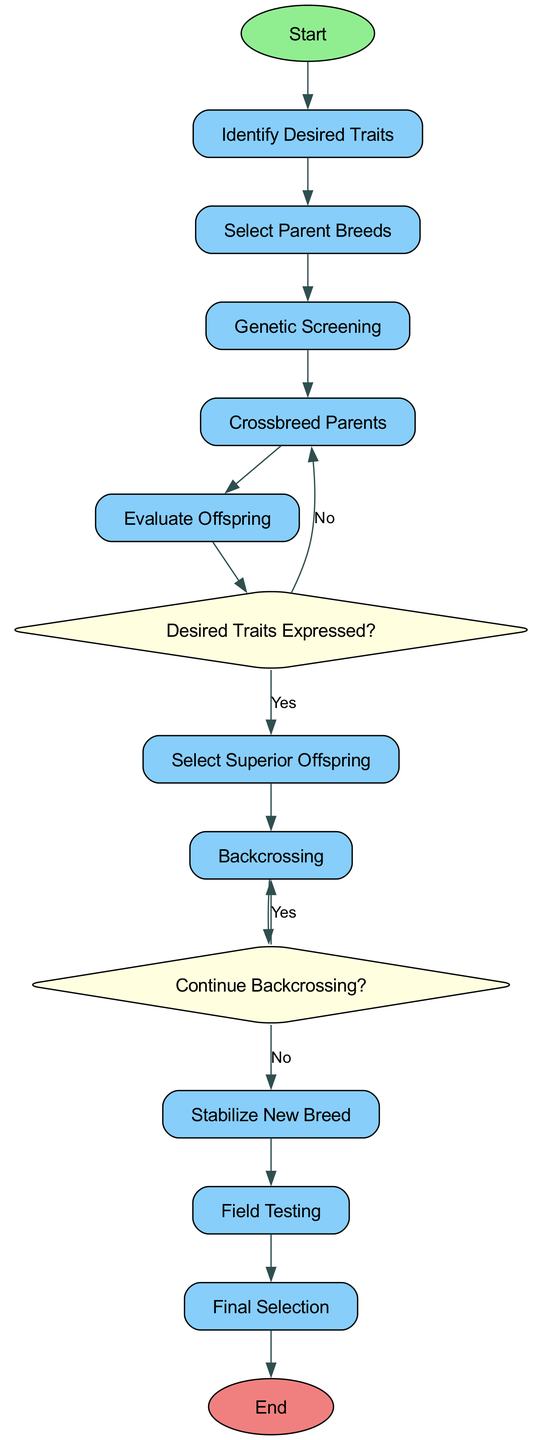What is the first activity in the diagram? The first activity listed in the activities section is "Identify Desired Traits," which is also indicated as the starting point of the diagram.
Answer: Identify Desired Traits How many decision points are present in the diagram? The diagram includes two decision points: "Desired Traits Expressed?" and "Continue Backcrossing?". Thus, the count is two.
Answer: 2 What activity follows the "Select Superior Offspring"? The "Select Superior Offspring" activity directly leads to "Backcrossing" as per the flow of the diagram.
Answer: Backcrossing If the answer to "Desired Traits Expressed?" is "No", where does the flow go next? When the response to "Desired Traits Expressed?" is "No", the flow returns to "Crossbreed Parents" for further breeding actions.
Answer: Crossbreed Parents What is the outcome after "Field Testing"? The outcome after "Field Testing" is the "Final Selection" activity, which represents the culmination of the process.
Answer: Final Selection What is the last node in the diagram? The last node in the diagram is "End," which signifies the conclusion of the crossbreeding procedure after final selection.
Answer: End What is the relationship between "Backcrossing" and "Continue Backcrossing?" "Backcrossing" precedes the "Continue Backcrossing?" decision point, indicating a flow where backcrossing occurs before evaluating if further backcrossing is necessary.
Answer: Precedes What does "Stabilize New Breed" lead to? "Stabilize New Breed" leads to "Field Testing," which is the next step in the process after stabilizing the new breed.
Answer: Field Testing What action is taken after "Genetic Screening"? After "Genetic Screening", the next action is "Crossbreed Parents" as indicated by the flow of the diagram.
Answer: Crossbreed Parents 